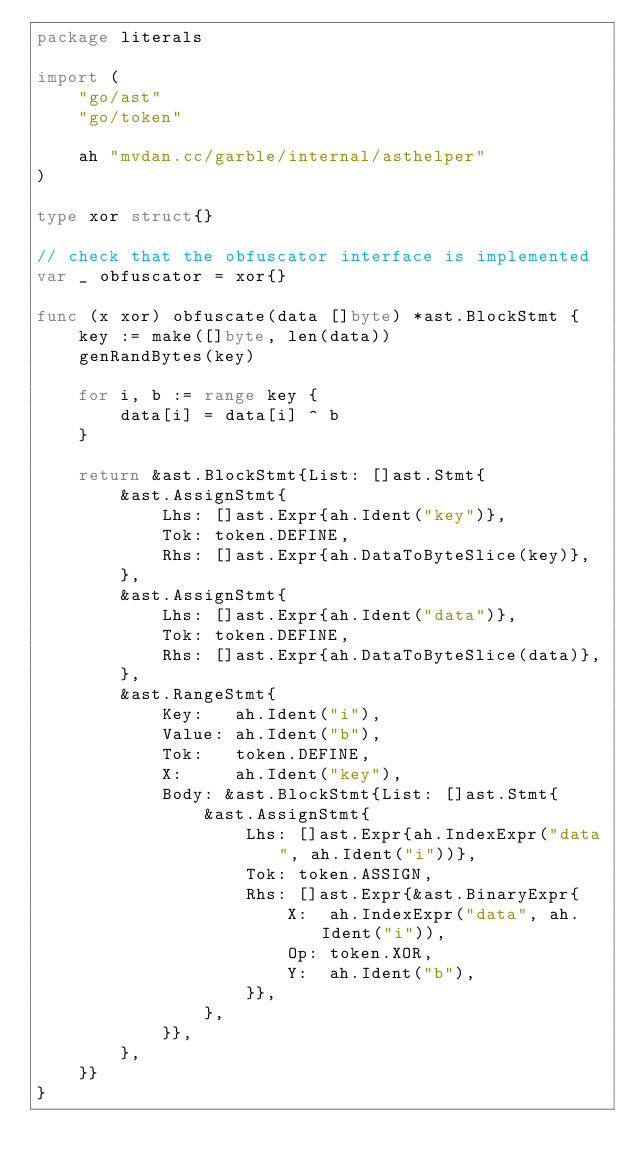Convert code to text. <code><loc_0><loc_0><loc_500><loc_500><_Go_>package literals

import (
	"go/ast"
	"go/token"

	ah "mvdan.cc/garble/internal/asthelper"
)

type xor struct{}

// check that the obfuscator interface is implemented
var _ obfuscator = xor{}

func (x xor) obfuscate(data []byte) *ast.BlockStmt {
	key := make([]byte, len(data))
	genRandBytes(key)

	for i, b := range key {
		data[i] = data[i] ^ b
	}

	return &ast.BlockStmt{List: []ast.Stmt{
		&ast.AssignStmt{
			Lhs: []ast.Expr{ah.Ident("key")},
			Tok: token.DEFINE,
			Rhs: []ast.Expr{ah.DataToByteSlice(key)},
		},
		&ast.AssignStmt{
			Lhs: []ast.Expr{ah.Ident("data")},
			Tok: token.DEFINE,
			Rhs: []ast.Expr{ah.DataToByteSlice(data)},
		},
		&ast.RangeStmt{
			Key:   ah.Ident("i"),
			Value: ah.Ident("b"),
			Tok:   token.DEFINE,
			X:     ah.Ident("key"),
			Body: &ast.BlockStmt{List: []ast.Stmt{
				&ast.AssignStmt{
					Lhs: []ast.Expr{ah.IndexExpr("data", ah.Ident("i"))},
					Tok: token.ASSIGN,
					Rhs: []ast.Expr{&ast.BinaryExpr{
						X:  ah.IndexExpr("data", ah.Ident("i")),
						Op: token.XOR,
						Y:  ah.Ident("b"),
					}},
				},
			}},
		},
	}}
}
</code> 